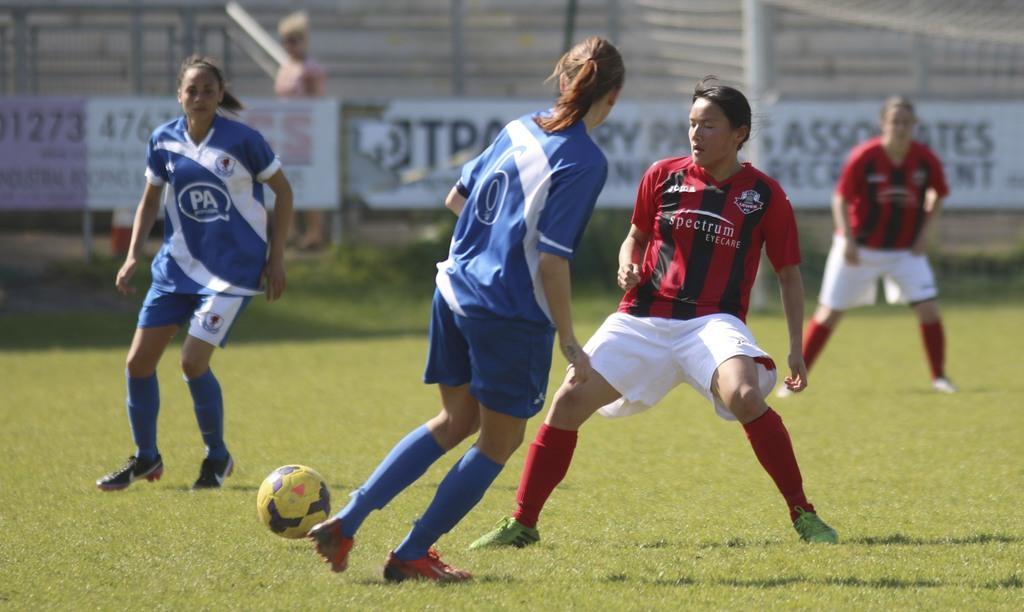How would you summarize this image in a sentence or two? These 2 persons are running as there is a leg movement. Beside this woman there is a ball. This 2 persons are standing on grass. Far there are banners in white color. 